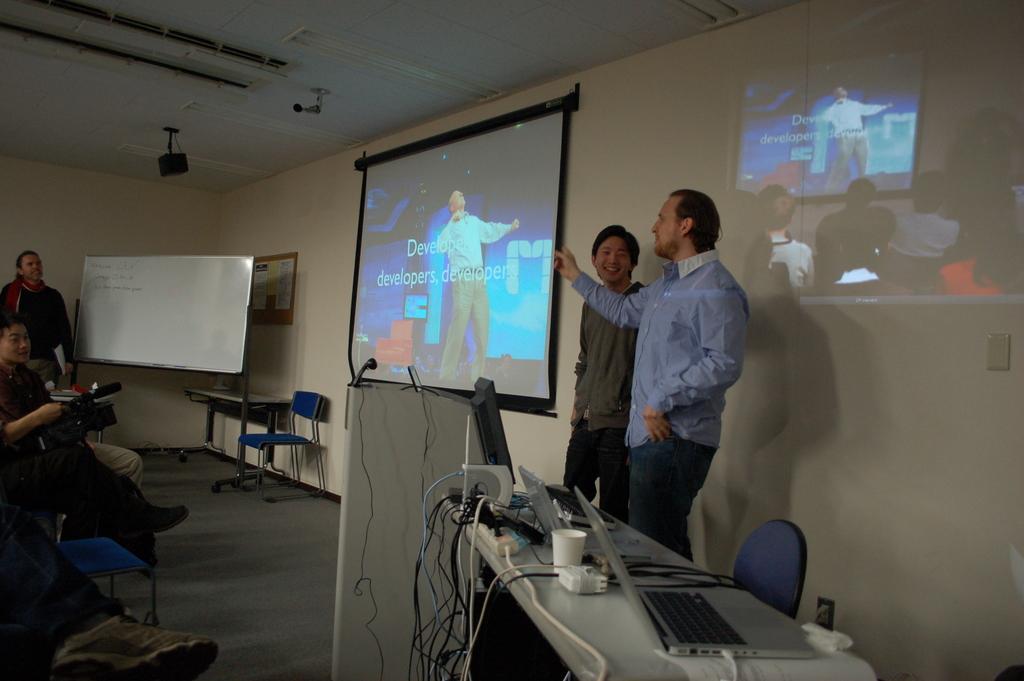In one or two sentences, can you explain what this image depicts? In the center of the image there is a screen. On the right side of the image there are persons, paper, table, glass, monitor. On the left side of the image there is a board, persons, chair. In the background there is a wall. 